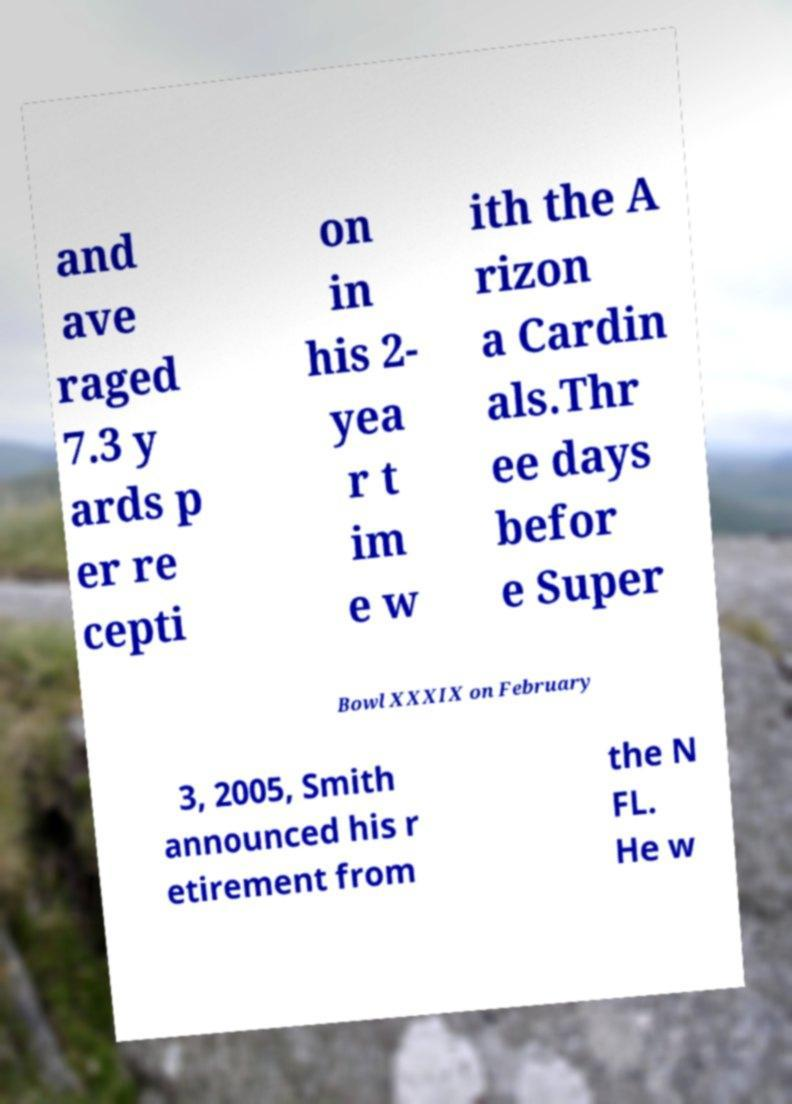What messages or text are displayed in this image? I need them in a readable, typed format. and ave raged 7.3 y ards p er re cepti on in his 2- yea r t im e w ith the A rizon a Cardin als.Thr ee days befor e Super Bowl XXXIX on February 3, 2005, Smith announced his r etirement from the N FL. He w 